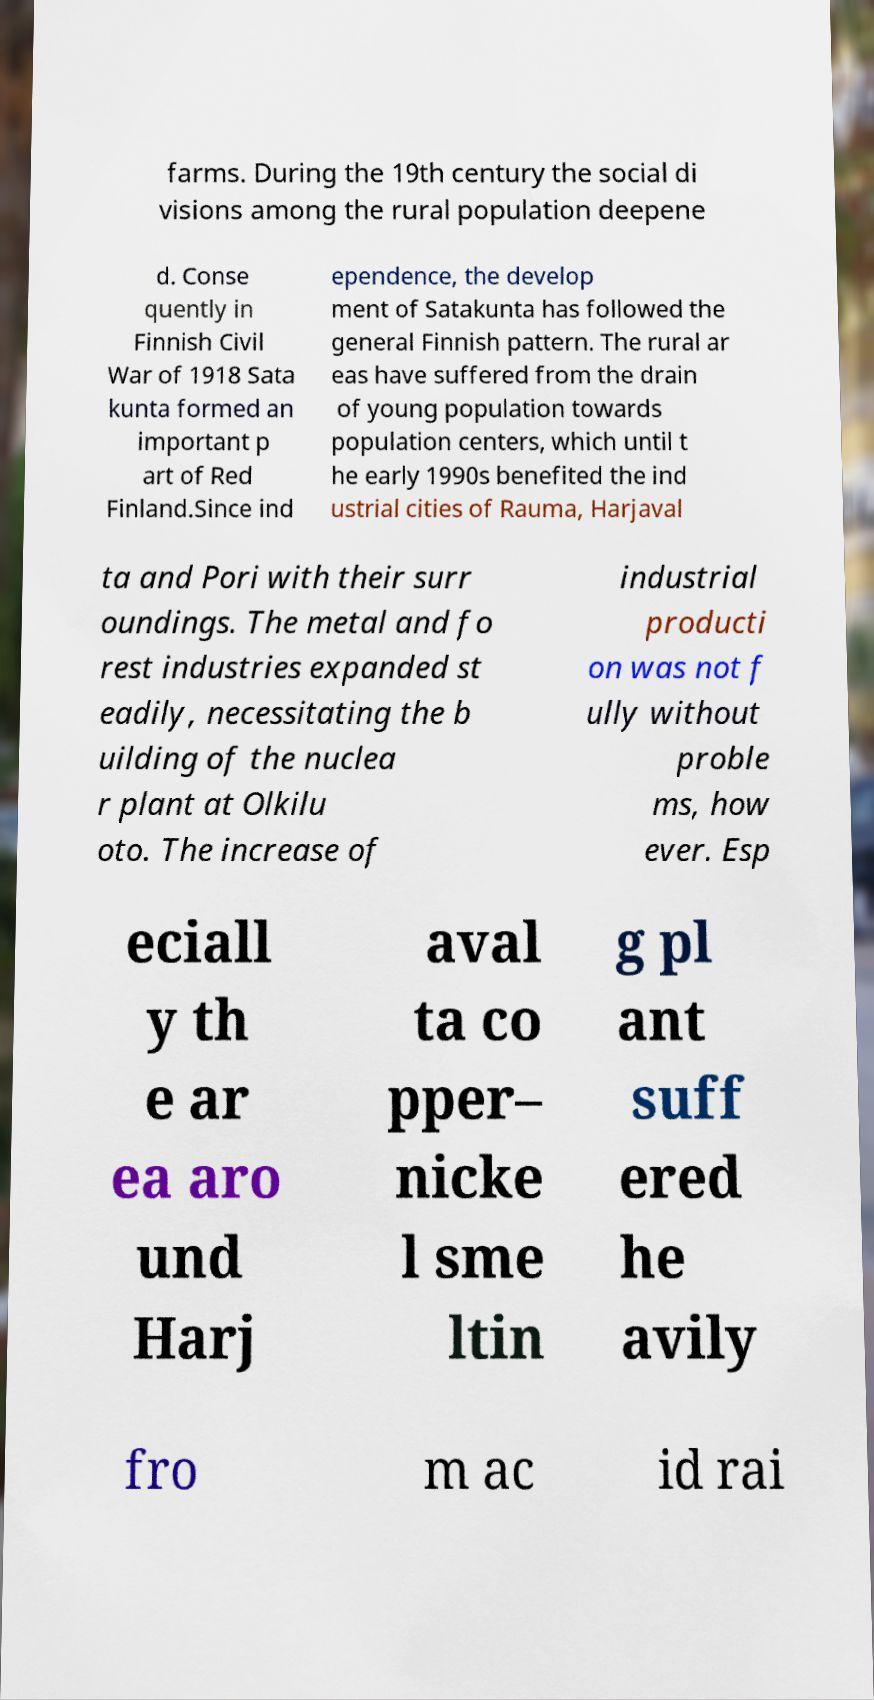Can you read and provide the text displayed in the image?This photo seems to have some interesting text. Can you extract and type it out for me? farms. During the 19th century the social di visions among the rural population deepene d. Conse quently in Finnish Civil War of 1918 Sata kunta formed an important p art of Red Finland.Since ind ependence, the develop ment of Satakunta has followed the general Finnish pattern. The rural ar eas have suffered from the drain of young population towards population centers, which until t he early 1990s benefited the ind ustrial cities of Rauma, Harjaval ta and Pori with their surr oundings. The metal and fo rest industries expanded st eadily, necessitating the b uilding of the nuclea r plant at Olkilu oto. The increase of industrial producti on was not f ully without proble ms, how ever. Esp eciall y th e ar ea aro und Harj aval ta co pper– nicke l sme ltin g pl ant suff ered he avily fro m ac id rai 